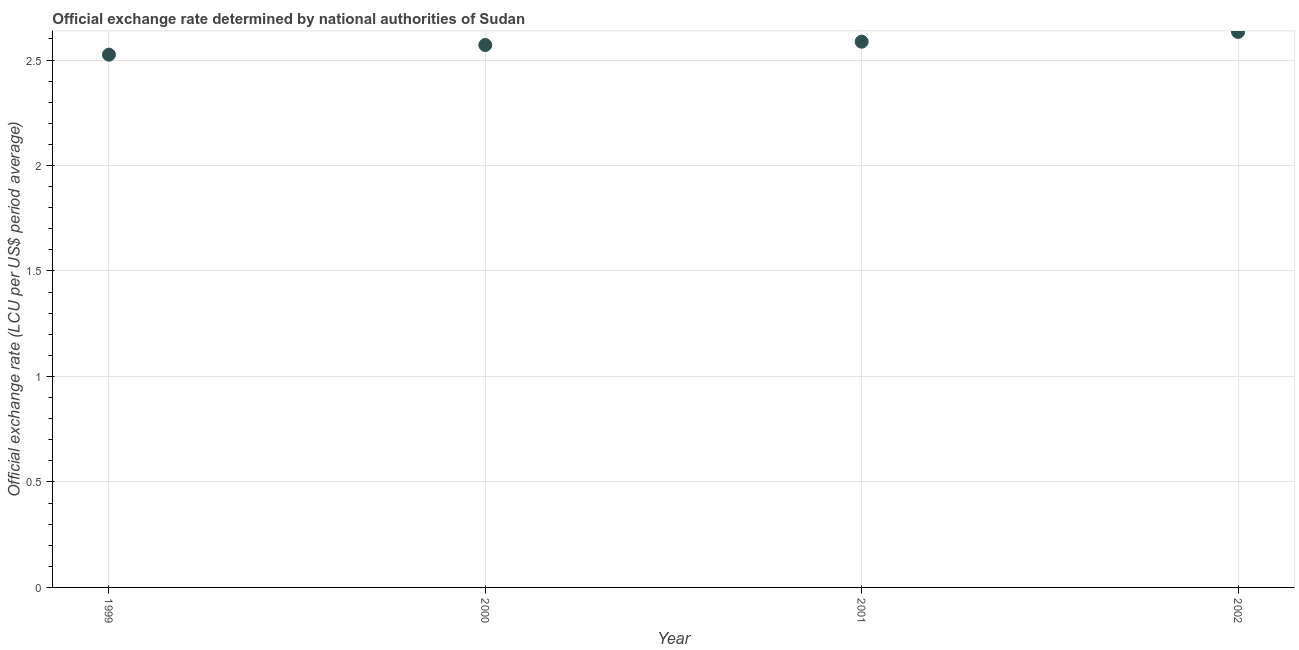What is the official exchange rate in 2002?
Provide a succinct answer. 2.63. Across all years, what is the maximum official exchange rate?
Your answer should be compact. 2.63. Across all years, what is the minimum official exchange rate?
Your answer should be compact. 2.53. In which year was the official exchange rate maximum?
Offer a terse response. 2002. In which year was the official exchange rate minimum?
Ensure brevity in your answer.  1999. What is the sum of the official exchange rate?
Offer a very short reply. 10.32. What is the difference between the official exchange rate in 1999 and 2001?
Make the answer very short. -0.06. What is the average official exchange rate per year?
Offer a terse response. 2.58. What is the median official exchange rate?
Your answer should be very brief. 2.58. What is the ratio of the official exchange rate in 1999 to that in 2000?
Your answer should be compact. 0.98. Is the difference between the official exchange rate in 2000 and 2001 greater than the difference between any two years?
Make the answer very short. No. What is the difference between the highest and the second highest official exchange rate?
Provide a short and direct response. 0.05. What is the difference between the highest and the lowest official exchange rate?
Provide a short and direct response. 0.11. How many dotlines are there?
Your answer should be compact. 1. Does the graph contain grids?
Give a very brief answer. Yes. What is the title of the graph?
Provide a succinct answer. Official exchange rate determined by national authorities of Sudan. What is the label or title of the X-axis?
Offer a very short reply. Year. What is the label or title of the Y-axis?
Provide a succinct answer. Official exchange rate (LCU per US$ period average). What is the Official exchange rate (LCU per US$ period average) in 1999?
Your answer should be very brief. 2.53. What is the Official exchange rate (LCU per US$ period average) in 2000?
Ensure brevity in your answer.  2.57. What is the Official exchange rate (LCU per US$ period average) in 2001?
Make the answer very short. 2.59. What is the Official exchange rate (LCU per US$ period average) in 2002?
Your response must be concise. 2.63. What is the difference between the Official exchange rate (LCU per US$ period average) in 1999 and 2000?
Your answer should be compact. -0.05. What is the difference between the Official exchange rate (LCU per US$ period average) in 1999 and 2001?
Give a very brief answer. -0.06. What is the difference between the Official exchange rate (LCU per US$ period average) in 1999 and 2002?
Give a very brief answer. -0.11. What is the difference between the Official exchange rate (LCU per US$ period average) in 2000 and 2001?
Your answer should be very brief. -0.02. What is the difference between the Official exchange rate (LCU per US$ period average) in 2000 and 2002?
Your response must be concise. -0.06. What is the difference between the Official exchange rate (LCU per US$ period average) in 2001 and 2002?
Keep it short and to the point. -0.05. What is the ratio of the Official exchange rate (LCU per US$ period average) in 1999 to that in 2000?
Your answer should be compact. 0.98. What is the ratio of the Official exchange rate (LCU per US$ period average) in 1999 to that in 2001?
Your answer should be compact. 0.98. What is the ratio of the Official exchange rate (LCU per US$ period average) in 2000 to that in 2001?
Your answer should be compact. 0.99. What is the ratio of the Official exchange rate (LCU per US$ period average) in 2001 to that in 2002?
Offer a very short reply. 0.98. 